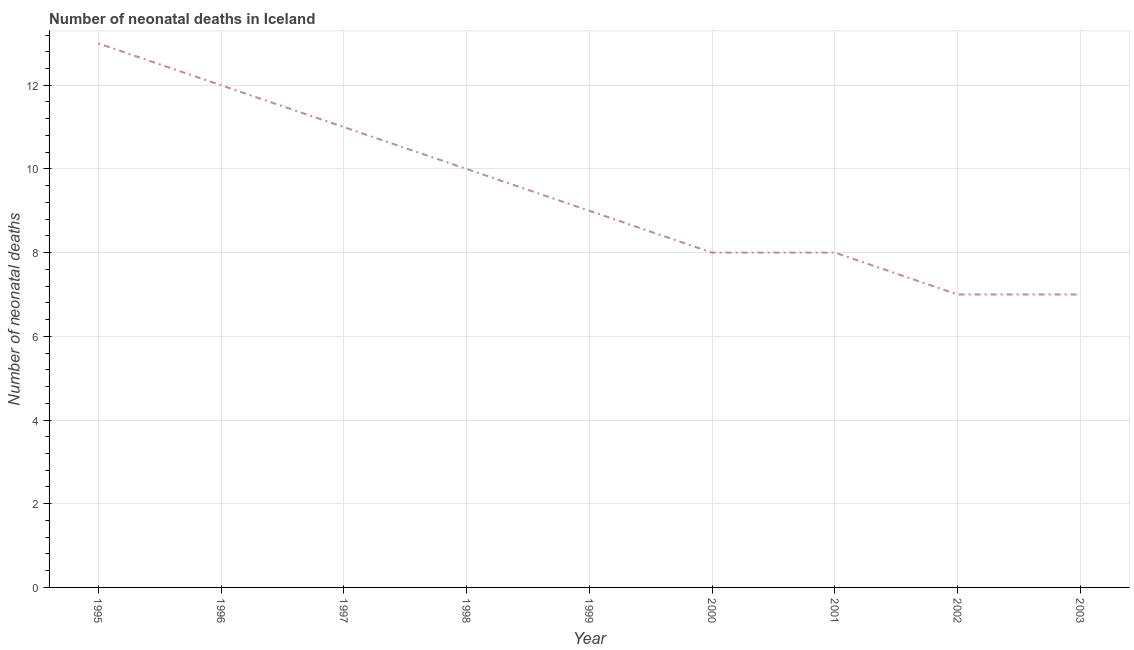What is the number of neonatal deaths in 1999?
Offer a very short reply. 9. Across all years, what is the maximum number of neonatal deaths?
Your answer should be compact. 13. Across all years, what is the minimum number of neonatal deaths?
Provide a succinct answer. 7. In which year was the number of neonatal deaths maximum?
Your response must be concise. 1995. In which year was the number of neonatal deaths minimum?
Keep it short and to the point. 2002. What is the sum of the number of neonatal deaths?
Your response must be concise. 85. What is the difference between the number of neonatal deaths in 1997 and 2003?
Your answer should be compact. 4. What is the average number of neonatal deaths per year?
Keep it short and to the point. 9.44. In how many years, is the number of neonatal deaths greater than 6 ?
Your answer should be very brief. 9. What is the ratio of the number of neonatal deaths in 2000 to that in 2003?
Your answer should be compact. 1.14. Is the difference between the number of neonatal deaths in 1997 and 2000 greater than the difference between any two years?
Provide a succinct answer. No. What is the difference between the highest and the second highest number of neonatal deaths?
Your answer should be very brief. 1. Is the sum of the number of neonatal deaths in 1996 and 2001 greater than the maximum number of neonatal deaths across all years?
Ensure brevity in your answer.  Yes. What is the difference between the highest and the lowest number of neonatal deaths?
Give a very brief answer. 6. In how many years, is the number of neonatal deaths greater than the average number of neonatal deaths taken over all years?
Your answer should be compact. 4. Does the number of neonatal deaths monotonically increase over the years?
Your answer should be very brief. No. What is the difference between two consecutive major ticks on the Y-axis?
Make the answer very short. 2. Does the graph contain any zero values?
Make the answer very short. No. What is the title of the graph?
Provide a short and direct response. Number of neonatal deaths in Iceland. What is the label or title of the X-axis?
Keep it short and to the point. Year. What is the label or title of the Y-axis?
Provide a succinct answer. Number of neonatal deaths. What is the Number of neonatal deaths in 1996?
Offer a terse response. 12. What is the Number of neonatal deaths in 1999?
Your response must be concise. 9. What is the Number of neonatal deaths in 2003?
Make the answer very short. 7. What is the difference between the Number of neonatal deaths in 1995 and 1996?
Your answer should be compact. 1. What is the difference between the Number of neonatal deaths in 1995 and 1999?
Provide a succinct answer. 4. What is the difference between the Number of neonatal deaths in 1996 and 1997?
Offer a very short reply. 1. What is the difference between the Number of neonatal deaths in 1996 and 2001?
Ensure brevity in your answer.  4. What is the difference between the Number of neonatal deaths in 1996 and 2002?
Ensure brevity in your answer.  5. What is the difference between the Number of neonatal deaths in 1997 and 1998?
Offer a very short reply. 1. What is the difference between the Number of neonatal deaths in 1997 and 2000?
Give a very brief answer. 3. What is the difference between the Number of neonatal deaths in 1997 and 2002?
Offer a terse response. 4. What is the difference between the Number of neonatal deaths in 1998 and 1999?
Offer a very short reply. 1. What is the difference between the Number of neonatal deaths in 1998 and 2000?
Your response must be concise. 2. What is the difference between the Number of neonatal deaths in 1998 and 2002?
Make the answer very short. 3. What is the difference between the Number of neonatal deaths in 1999 and 2001?
Your response must be concise. 1. What is the difference between the Number of neonatal deaths in 1999 and 2002?
Your answer should be very brief. 2. What is the difference between the Number of neonatal deaths in 1999 and 2003?
Ensure brevity in your answer.  2. What is the difference between the Number of neonatal deaths in 2001 and 2003?
Provide a short and direct response. 1. What is the ratio of the Number of neonatal deaths in 1995 to that in 1996?
Give a very brief answer. 1.08. What is the ratio of the Number of neonatal deaths in 1995 to that in 1997?
Keep it short and to the point. 1.18. What is the ratio of the Number of neonatal deaths in 1995 to that in 1999?
Ensure brevity in your answer.  1.44. What is the ratio of the Number of neonatal deaths in 1995 to that in 2000?
Provide a succinct answer. 1.62. What is the ratio of the Number of neonatal deaths in 1995 to that in 2001?
Provide a succinct answer. 1.62. What is the ratio of the Number of neonatal deaths in 1995 to that in 2002?
Make the answer very short. 1.86. What is the ratio of the Number of neonatal deaths in 1995 to that in 2003?
Your answer should be compact. 1.86. What is the ratio of the Number of neonatal deaths in 1996 to that in 1997?
Give a very brief answer. 1.09. What is the ratio of the Number of neonatal deaths in 1996 to that in 1998?
Your response must be concise. 1.2. What is the ratio of the Number of neonatal deaths in 1996 to that in 1999?
Give a very brief answer. 1.33. What is the ratio of the Number of neonatal deaths in 1996 to that in 2002?
Offer a very short reply. 1.71. What is the ratio of the Number of neonatal deaths in 1996 to that in 2003?
Make the answer very short. 1.71. What is the ratio of the Number of neonatal deaths in 1997 to that in 1999?
Provide a succinct answer. 1.22. What is the ratio of the Number of neonatal deaths in 1997 to that in 2000?
Offer a terse response. 1.38. What is the ratio of the Number of neonatal deaths in 1997 to that in 2001?
Give a very brief answer. 1.38. What is the ratio of the Number of neonatal deaths in 1997 to that in 2002?
Your answer should be compact. 1.57. What is the ratio of the Number of neonatal deaths in 1997 to that in 2003?
Offer a terse response. 1.57. What is the ratio of the Number of neonatal deaths in 1998 to that in 1999?
Give a very brief answer. 1.11. What is the ratio of the Number of neonatal deaths in 1998 to that in 2000?
Make the answer very short. 1.25. What is the ratio of the Number of neonatal deaths in 1998 to that in 2002?
Your answer should be very brief. 1.43. What is the ratio of the Number of neonatal deaths in 1998 to that in 2003?
Offer a terse response. 1.43. What is the ratio of the Number of neonatal deaths in 1999 to that in 2000?
Make the answer very short. 1.12. What is the ratio of the Number of neonatal deaths in 1999 to that in 2001?
Your response must be concise. 1.12. What is the ratio of the Number of neonatal deaths in 1999 to that in 2002?
Offer a very short reply. 1.29. What is the ratio of the Number of neonatal deaths in 1999 to that in 2003?
Ensure brevity in your answer.  1.29. What is the ratio of the Number of neonatal deaths in 2000 to that in 2002?
Your response must be concise. 1.14. What is the ratio of the Number of neonatal deaths in 2000 to that in 2003?
Offer a terse response. 1.14. What is the ratio of the Number of neonatal deaths in 2001 to that in 2002?
Your response must be concise. 1.14. What is the ratio of the Number of neonatal deaths in 2001 to that in 2003?
Offer a terse response. 1.14. 